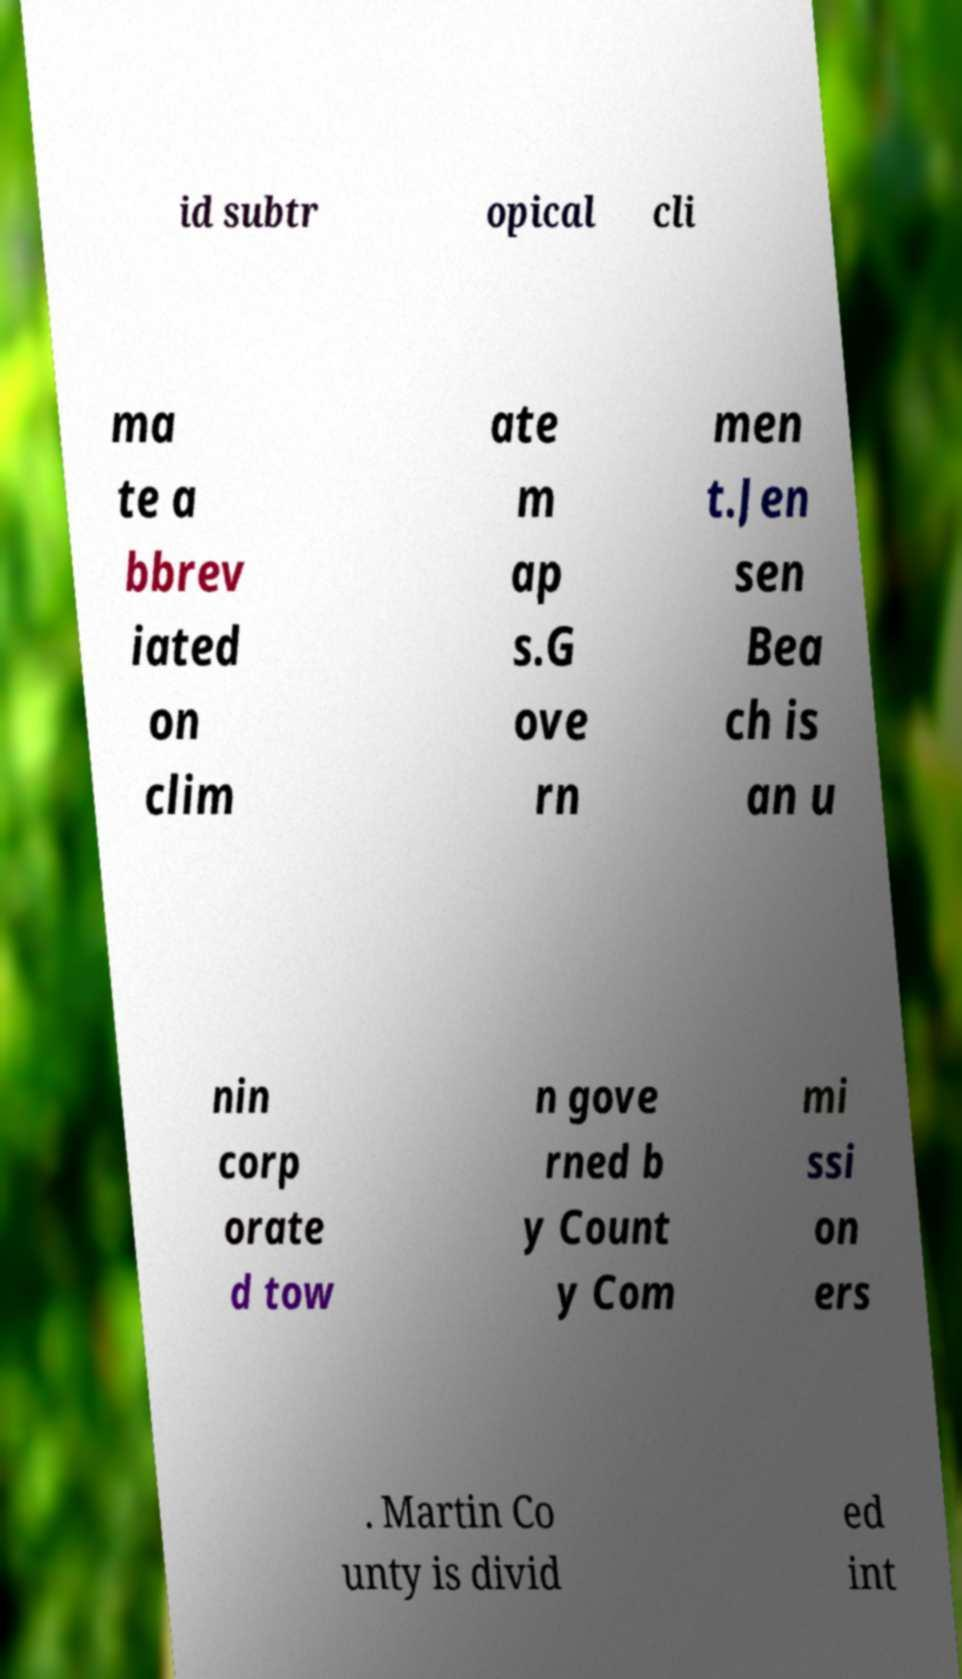Could you assist in decoding the text presented in this image and type it out clearly? id subtr opical cli ma te a bbrev iated on clim ate m ap s.G ove rn men t.Jen sen Bea ch is an u nin corp orate d tow n gove rned b y Count y Com mi ssi on ers . Martin Co unty is divid ed int 